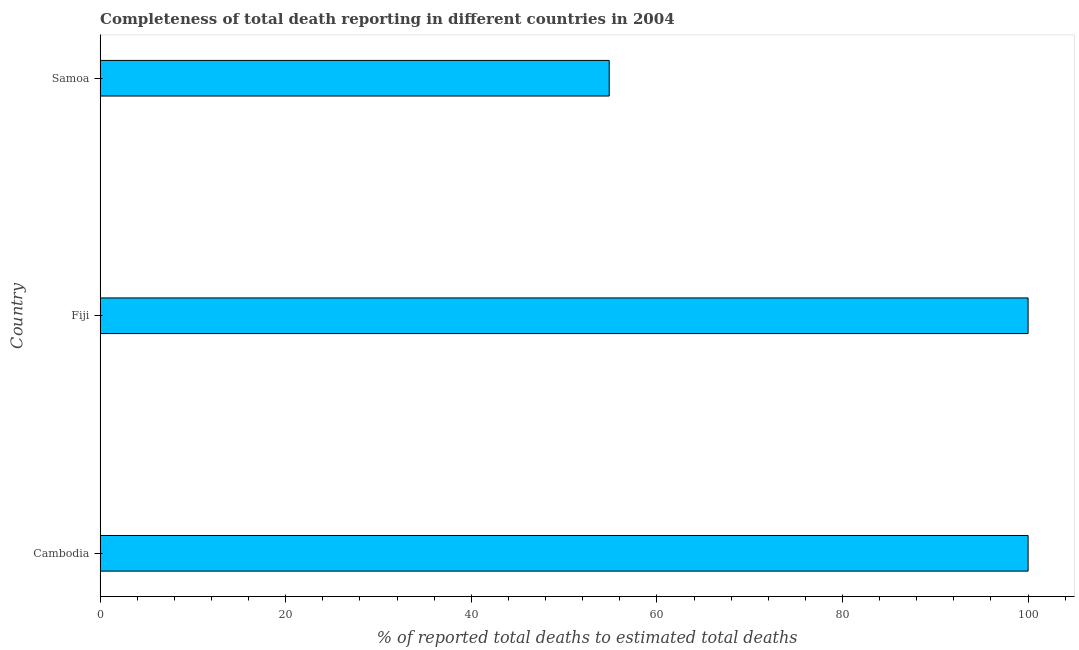Does the graph contain grids?
Ensure brevity in your answer.  No. What is the title of the graph?
Keep it short and to the point. Completeness of total death reporting in different countries in 2004. What is the label or title of the X-axis?
Your answer should be compact. % of reported total deaths to estimated total deaths. What is the label or title of the Y-axis?
Ensure brevity in your answer.  Country. What is the completeness of total death reports in Samoa?
Your answer should be very brief. 54.86. Across all countries, what is the maximum completeness of total death reports?
Give a very brief answer. 100. Across all countries, what is the minimum completeness of total death reports?
Your response must be concise. 54.86. In which country was the completeness of total death reports maximum?
Offer a terse response. Cambodia. In which country was the completeness of total death reports minimum?
Offer a very short reply. Samoa. What is the sum of the completeness of total death reports?
Your response must be concise. 254.86. What is the difference between the completeness of total death reports in Cambodia and Fiji?
Your answer should be very brief. 0. What is the average completeness of total death reports per country?
Ensure brevity in your answer.  84.95. What is the median completeness of total death reports?
Give a very brief answer. 100. In how many countries, is the completeness of total death reports greater than 20 %?
Make the answer very short. 3. What is the ratio of the completeness of total death reports in Fiji to that in Samoa?
Offer a terse response. 1.82. Is the difference between the completeness of total death reports in Fiji and Samoa greater than the difference between any two countries?
Offer a terse response. Yes. What is the difference between the highest and the lowest completeness of total death reports?
Your answer should be very brief. 45.14. Are all the bars in the graph horizontal?
Ensure brevity in your answer.  Yes. What is the % of reported total deaths to estimated total deaths of Fiji?
Your answer should be compact. 100. What is the % of reported total deaths to estimated total deaths in Samoa?
Your answer should be very brief. 54.86. What is the difference between the % of reported total deaths to estimated total deaths in Cambodia and Fiji?
Your response must be concise. 0. What is the difference between the % of reported total deaths to estimated total deaths in Cambodia and Samoa?
Your response must be concise. 45.14. What is the difference between the % of reported total deaths to estimated total deaths in Fiji and Samoa?
Offer a terse response. 45.14. What is the ratio of the % of reported total deaths to estimated total deaths in Cambodia to that in Samoa?
Provide a short and direct response. 1.82. What is the ratio of the % of reported total deaths to estimated total deaths in Fiji to that in Samoa?
Ensure brevity in your answer.  1.82. 